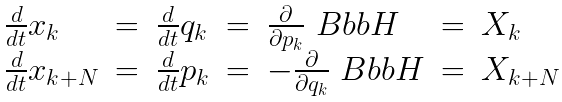Convert formula to latex. <formula><loc_0><loc_0><loc_500><loc_500>\begin{array} { l l l l l l l } \frac { d } { d t } x _ { k } & = & \frac { d } { d t } q _ { k } & = & \frac { \partial } { \partial p _ { k } } { \ B b b H } & = & X _ { k } \\ \frac { d } { d t } x _ { k + N } & = & \frac { d } { d t } p _ { k } & = & - \frac { \partial } { \partial q _ { k } } { \ B b b H } & = & X _ { k + N } \end{array}</formula> 